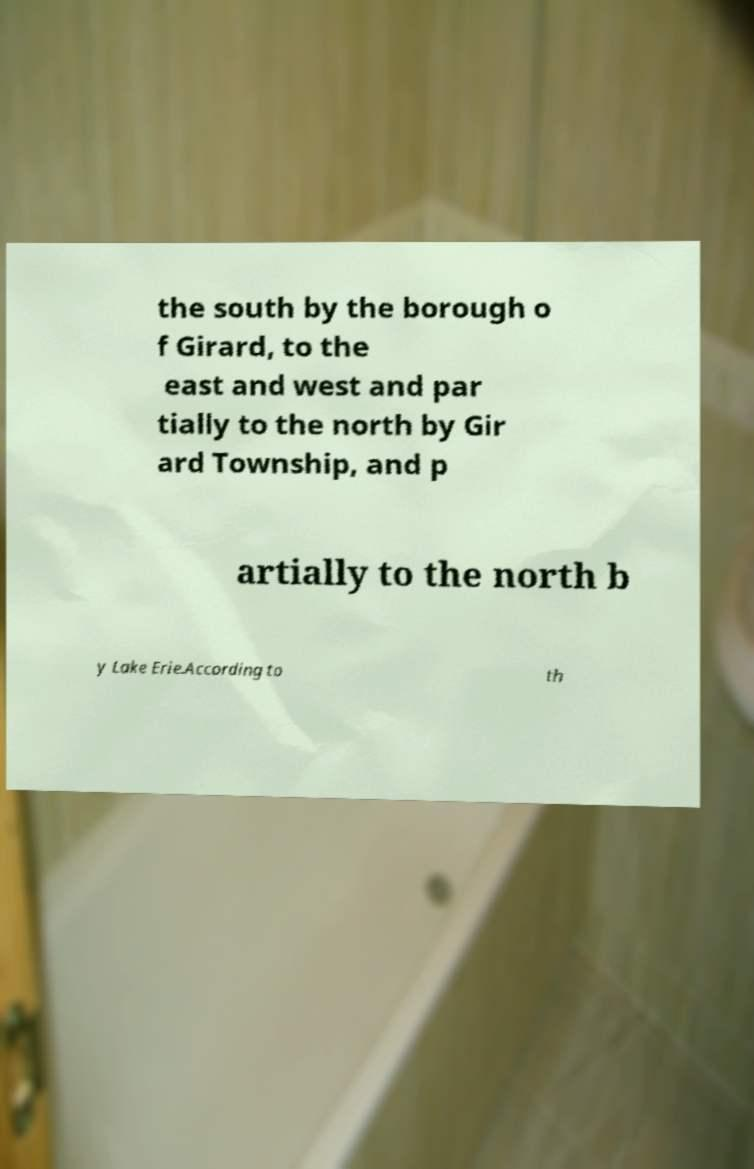Can you accurately transcribe the text from the provided image for me? the south by the borough o f Girard, to the east and west and par tially to the north by Gir ard Township, and p artially to the north b y Lake Erie.According to th 